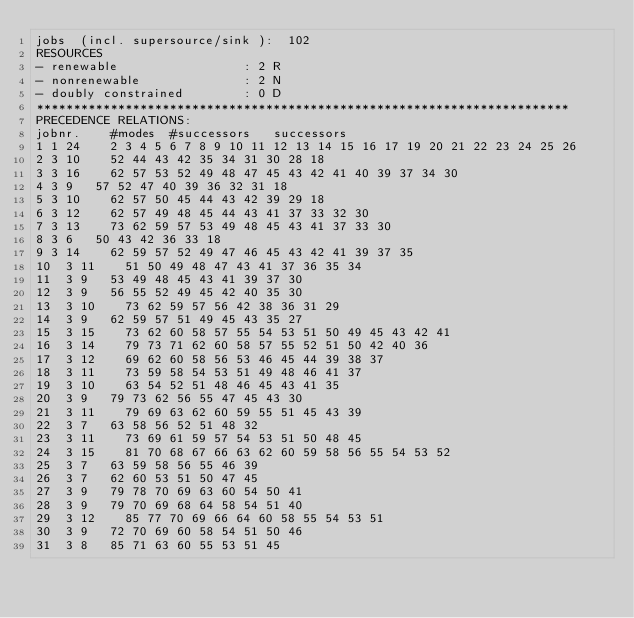<code> <loc_0><loc_0><loc_500><loc_500><_ObjectiveC_>jobs  (incl. supersource/sink ):	102
RESOURCES
- renewable                 : 2 R
- nonrenewable              : 2 N
- doubly constrained        : 0 D
************************************************************************
PRECEDENCE RELATIONS:
jobnr.    #modes  #successors   successors
1	1	24		2 3 4 5 6 7 8 9 10 11 12 13 14 15 16 17 19 20 21 22 23 24 25 26 
2	3	10		52 44 43 42 35 34 31 30 28 18 
3	3	16		62 57 53 52 49 48 47 45 43 42 41 40 39 37 34 30 
4	3	9		57 52 47 40 39 36 32 31 18 
5	3	10		62 57 50 45 44 43 42 39 29 18 
6	3	12		62 57 49 48 45 44 43 41 37 33 32 30 
7	3	13		73 62 59 57 53 49 48 45 43 41 37 33 30 
8	3	6		50 43 42 36 33 18 
9	3	14		62 59 57 52 49 47 46 45 43 42 41 39 37 35 
10	3	11		51 50 49 48 47 43 41 37 36 35 34 
11	3	9		53 49 48 45 43 41 39 37 30 
12	3	9		56 55 52 49 45 42 40 35 30 
13	3	10		73 62 59 57 56 42 38 36 31 29 
14	3	9		62 59 57 51 49 45 43 35 27 
15	3	15		73 62 60 58 57 55 54 53 51 50 49 45 43 42 41 
16	3	14		79 73 71 62 60 58 57 55 52 51 50 42 40 36 
17	3	12		69 62 60 58 56 53 46 45 44 39 38 37 
18	3	11		73 59 58 54 53 51 49 48 46 41 37 
19	3	10		63 54 52 51 48 46 45 43 41 35 
20	3	9		79 73 62 56 55 47 45 43 30 
21	3	11		79 69 63 62 60 59 55 51 45 43 39 
22	3	7		63 58 56 52 51 48 32 
23	3	11		73 69 61 59 57 54 53 51 50 48 45 
24	3	15		81 70 68 67 66 63 62 60 59 58 56 55 54 53 52 
25	3	7		63 59 58 56 55 46 39 
26	3	7		62 60 53 51 50 47 45 
27	3	9		79 78 70 69 63 60 54 50 41 
28	3	9		79 70 69 68 64 58 54 51 40 
29	3	12		85 77 70 69 66 64 60 58 55 54 53 51 
30	3	9		72 70 69 60 58 54 51 50 46 
31	3	8		85 71 63 60 55 53 51 45 </code> 